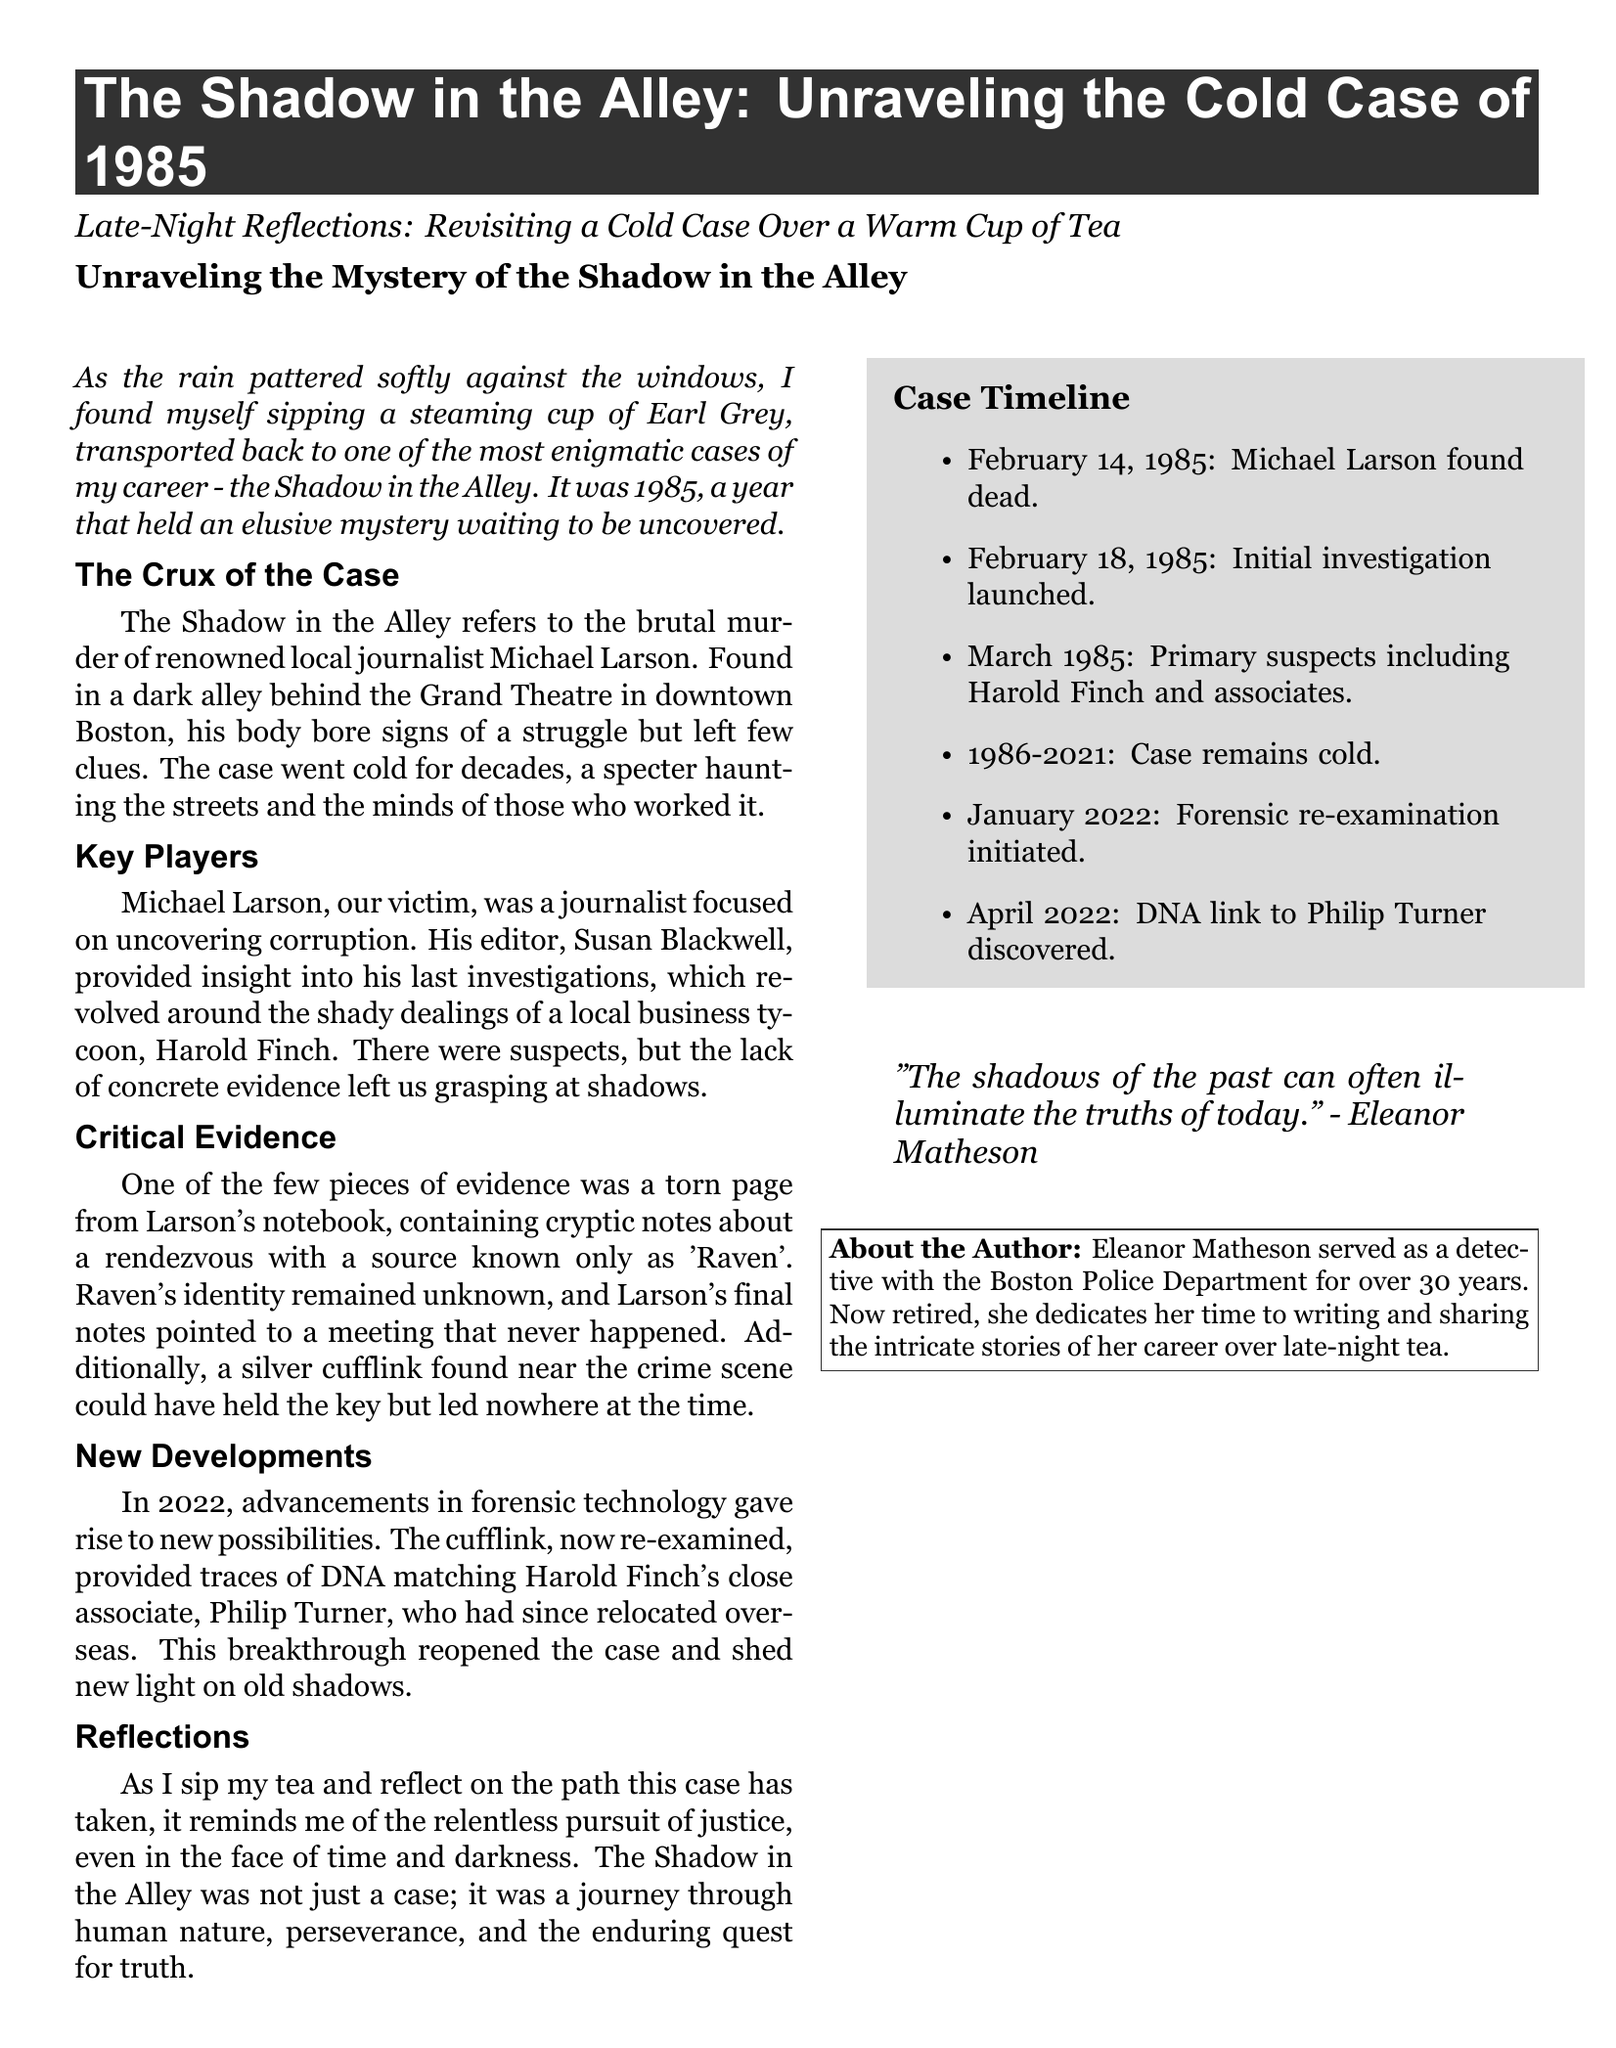What is the title of the case? The title is specified at the beginning of the document, which is focused on the cold case from 1985.
Answer: The Shadow in the Alley Who was the victim in the case? The document explicitly names the victim of the murder, detailing his background as a journalist.
Answer: Michael Larson What item was found near the crime scene? The document lists specific pieces of evidence, including the cufflink, which is crucial to the investigation.
Answer: A silver cufflink What year did the murder occur? The year of the murder is noted right at the start of the document as part of the case's context.
Answer: 1985 Who was the local business tycoon mentioned? The document identifies a key figure linked to the investigation, who had suspicious dealings.
Answer: Harold Finch What was the profession of Michael Larson? The document describes the victim's profession, highlighting his investigative work on corruption.
Answer: Journalist When was the forensic re-examination initiated? The timeline in the sidebar provides specific dates related to significant developments in the case.
Answer: January 2022 What cryptic name was found in Larson's notes? The case involves an enigmatic source mentioned in the victim's notes, which is key to unraveling the mystery.
Answer: Raven Who is the author of the article? The end of the document provides information about the author, specifying her background and experience.
Answer: Eleanor Matheson 